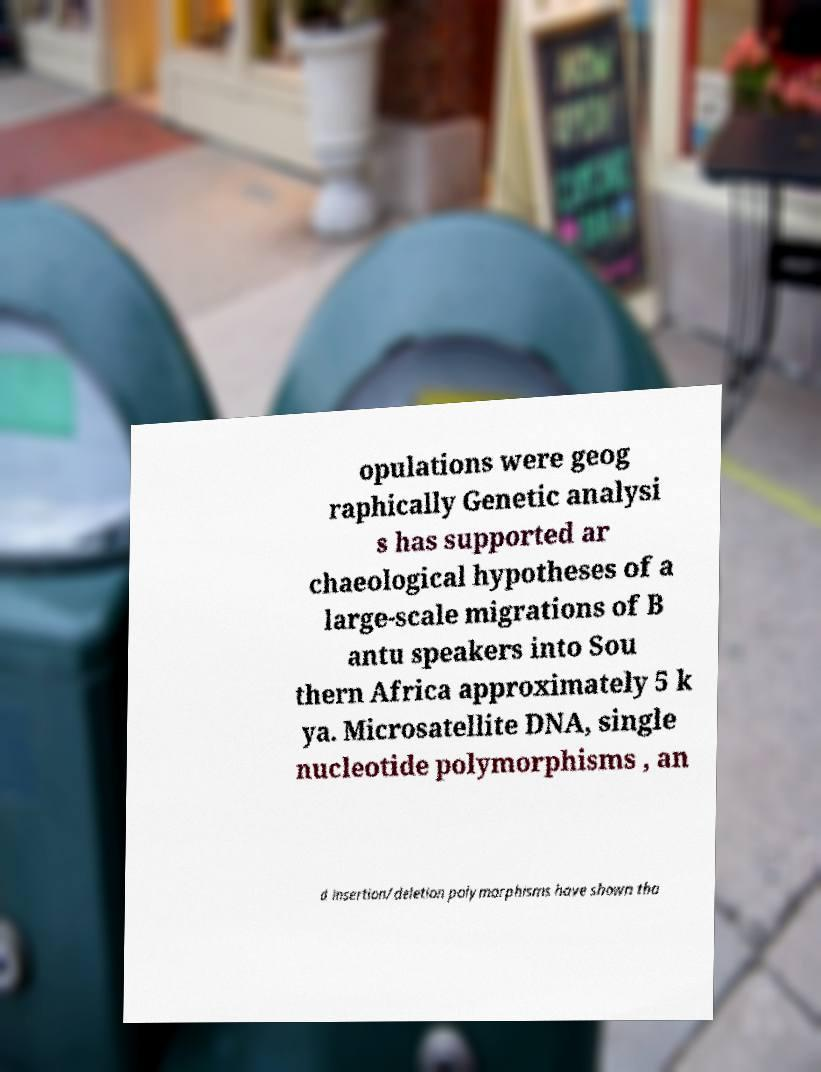There's text embedded in this image that I need extracted. Can you transcribe it verbatim? opulations were geog raphically Genetic analysi s has supported ar chaeological hypotheses of a large-scale migrations of B antu speakers into Sou thern Africa approximately 5 k ya. Microsatellite DNA, single nucleotide polymorphisms , an d insertion/deletion polymorphisms have shown tha 